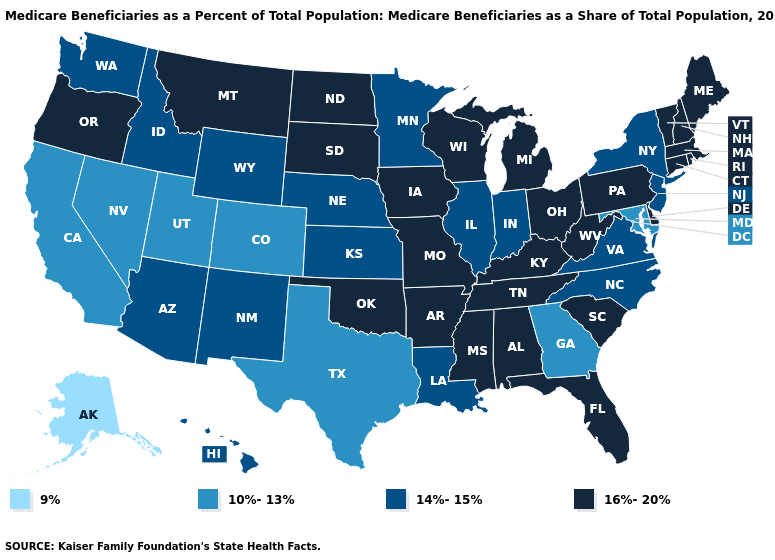What is the value of Kentucky?
Be succinct. 16%-20%. Name the states that have a value in the range 9%?
Answer briefly. Alaska. What is the value of Delaware?
Short answer required. 16%-20%. What is the lowest value in the USA?
Be succinct. 9%. Name the states that have a value in the range 10%-13%?
Short answer required. California, Colorado, Georgia, Maryland, Nevada, Texas, Utah. Name the states that have a value in the range 9%?
Keep it brief. Alaska. What is the value of Mississippi?
Short answer required. 16%-20%. Name the states that have a value in the range 16%-20%?
Answer briefly. Alabama, Arkansas, Connecticut, Delaware, Florida, Iowa, Kentucky, Maine, Massachusetts, Michigan, Mississippi, Missouri, Montana, New Hampshire, North Dakota, Ohio, Oklahoma, Oregon, Pennsylvania, Rhode Island, South Carolina, South Dakota, Tennessee, Vermont, West Virginia, Wisconsin. Which states hav the highest value in the Northeast?
Be succinct. Connecticut, Maine, Massachusetts, New Hampshire, Pennsylvania, Rhode Island, Vermont. Among the states that border New Hampshire , which have the highest value?
Give a very brief answer. Maine, Massachusetts, Vermont. Among the states that border Kentucky , does Illinois have the lowest value?
Answer briefly. Yes. Which states hav the highest value in the MidWest?
Write a very short answer. Iowa, Michigan, Missouri, North Dakota, Ohio, South Dakota, Wisconsin. Does the map have missing data?
Keep it brief. No. What is the value of Wisconsin?
Give a very brief answer. 16%-20%. Does New Hampshire have a lower value than Texas?
Concise answer only. No. 